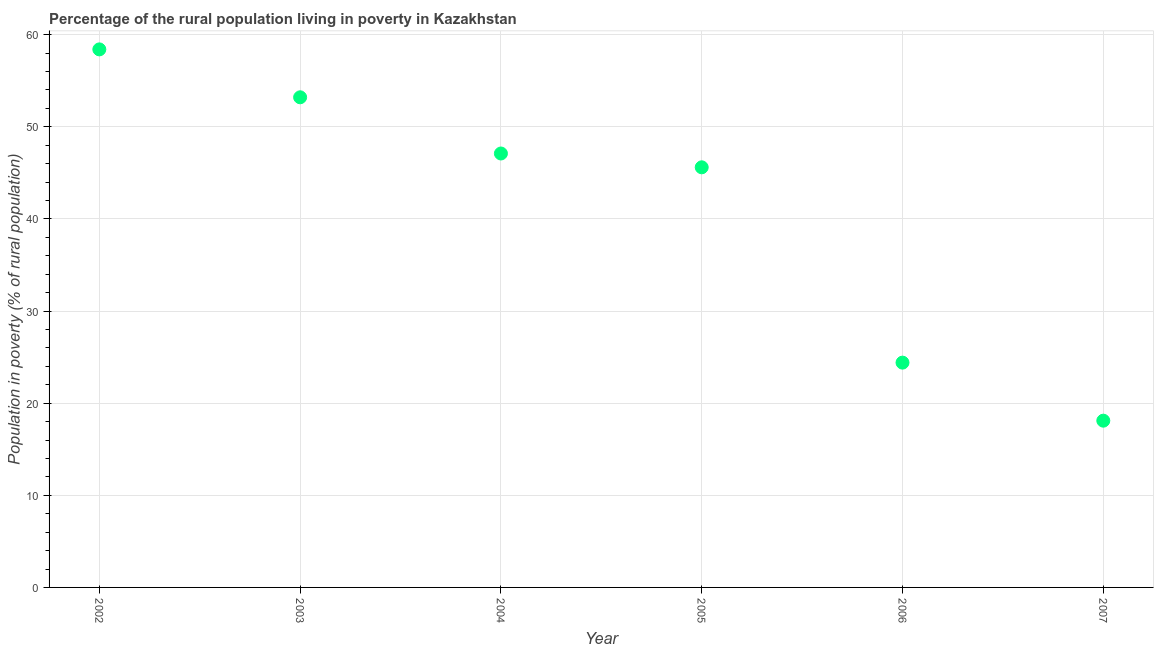What is the percentage of rural population living below poverty line in 2002?
Provide a short and direct response. 58.4. Across all years, what is the maximum percentage of rural population living below poverty line?
Offer a very short reply. 58.4. What is the sum of the percentage of rural population living below poverty line?
Your answer should be very brief. 246.8. What is the difference between the percentage of rural population living below poverty line in 2006 and 2007?
Keep it short and to the point. 6.3. What is the average percentage of rural population living below poverty line per year?
Offer a terse response. 41.13. What is the median percentage of rural population living below poverty line?
Provide a short and direct response. 46.35. In how many years, is the percentage of rural population living below poverty line greater than 40 %?
Your answer should be very brief. 4. Do a majority of the years between 2003 and 2002 (inclusive) have percentage of rural population living below poverty line greater than 42 %?
Your answer should be compact. No. What is the ratio of the percentage of rural population living below poverty line in 2003 to that in 2004?
Make the answer very short. 1.13. What is the difference between the highest and the second highest percentage of rural population living below poverty line?
Ensure brevity in your answer.  5.2. Is the sum of the percentage of rural population living below poverty line in 2003 and 2007 greater than the maximum percentage of rural population living below poverty line across all years?
Your answer should be very brief. Yes. What is the difference between the highest and the lowest percentage of rural population living below poverty line?
Provide a succinct answer. 40.3. In how many years, is the percentage of rural population living below poverty line greater than the average percentage of rural population living below poverty line taken over all years?
Offer a very short reply. 4. Does the percentage of rural population living below poverty line monotonically increase over the years?
Provide a succinct answer. No. How many years are there in the graph?
Make the answer very short. 6. What is the difference between two consecutive major ticks on the Y-axis?
Make the answer very short. 10. Are the values on the major ticks of Y-axis written in scientific E-notation?
Provide a short and direct response. No. Does the graph contain grids?
Give a very brief answer. Yes. What is the title of the graph?
Your response must be concise. Percentage of the rural population living in poverty in Kazakhstan. What is the label or title of the Y-axis?
Keep it short and to the point. Population in poverty (% of rural population). What is the Population in poverty (% of rural population) in 2002?
Your response must be concise. 58.4. What is the Population in poverty (% of rural population) in 2003?
Offer a very short reply. 53.2. What is the Population in poverty (% of rural population) in 2004?
Your response must be concise. 47.1. What is the Population in poverty (% of rural population) in 2005?
Give a very brief answer. 45.6. What is the Population in poverty (% of rural population) in 2006?
Make the answer very short. 24.4. What is the Population in poverty (% of rural population) in 2007?
Your answer should be compact. 18.1. What is the difference between the Population in poverty (% of rural population) in 2002 and 2004?
Keep it short and to the point. 11.3. What is the difference between the Population in poverty (% of rural population) in 2002 and 2006?
Offer a terse response. 34. What is the difference between the Population in poverty (% of rural population) in 2002 and 2007?
Offer a terse response. 40.3. What is the difference between the Population in poverty (% of rural population) in 2003 and 2005?
Provide a succinct answer. 7.6. What is the difference between the Population in poverty (% of rural population) in 2003 and 2006?
Make the answer very short. 28.8. What is the difference between the Population in poverty (% of rural population) in 2003 and 2007?
Offer a terse response. 35.1. What is the difference between the Population in poverty (% of rural population) in 2004 and 2006?
Offer a very short reply. 22.7. What is the difference between the Population in poverty (% of rural population) in 2004 and 2007?
Make the answer very short. 29. What is the difference between the Population in poverty (% of rural population) in 2005 and 2006?
Ensure brevity in your answer.  21.2. What is the ratio of the Population in poverty (% of rural population) in 2002 to that in 2003?
Offer a very short reply. 1.1. What is the ratio of the Population in poverty (% of rural population) in 2002 to that in 2004?
Provide a succinct answer. 1.24. What is the ratio of the Population in poverty (% of rural population) in 2002 to that in 2005?
Give a very brief answer. 1.28. What is the ratio of the Population in poverty (% of rural population) in 2002 to that in 2006?
Your answer should be compact. 2.39. What is the ratio of the Population in poverty (% of rural population) in 2002 to that in 2007?
Offer a very short reply. 3.23. What is the ratio of the Population in poverty (% of rural population) in 2003 to that in 2004?
Ensure brevity in your answer.  1.13. What is the ratio of the Population in poverty (% of rural population) in 2003 to that in 2005?
Keep it short and to the point. 1.17. What is the ratio of the Population in poverty (% of rural population) in 2003 to that in 2006?
Give a very brief answer. 2.18. What is the ratio of the Population in poverty (% of rural population) in 2003 to that in 2007?
Provide a succinct answer. 2.94. What is the ratio of the Population in poverty (% of rural population) in 2004 to that in 2005?
Give a very brief answer. 1.03. What is the ratio of the Population in poverty (% of rural population) in 2004 to that in 2006?
Offer a very short reply. 1.93. What is the ratio of the Population in poverty (% of rural population) in 2004 to that in 2007?
Your answer should be compact. 2.6. What is the ratio of the Population in poverty (% of rural population) in 2005 to that in 2006?
Offer a terse response. 1.87. What is the ratio of the Population in poverty (% of rural population) in 2005 to that in 2007?
Offer a very short reply. 2.52. What is the ratio of the Population in poverty (% of rural population) in 2006 to that in 2007?
Provide a succinct answer. 1.35. 